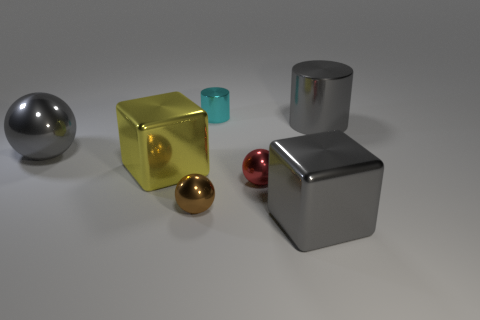Subtract all gray spheres. How many spheres are left? 2 Add 1 gray cylinders. How many objects exist? 8 Subtract all spheres. How many objects are left? 4 Subtract all cyan spheres. Subtract all brown blocks. How many spheres are left? 3 Add 6 tiny red metallic objects. How many tiny red metallic objects exist? 7 Subtract 0 yellow balls. How many objects are left? 7 Subtract all big gray metal balls. Subtract all small red metal balls. How many objects are left? 5 Add 1 gray metallic things. How many gray metallic things are left? 4 